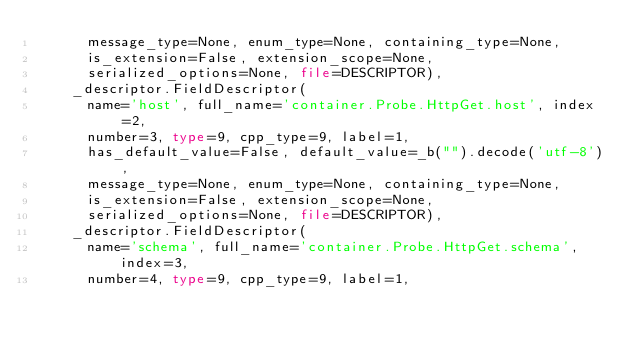<code> <loc_0><loc_0><loc_500><loc_500><_Python_>      message_type=None, enum_type=None, containing_type=None,
      is_extension=False, extension_scope=None,
      serialized_options=None, file=DESCRIPTOR),
    _descriptor.FieldDescriptor(
      name='host', full_name='container.Probe.HttpGet.host', index=2,
      number=3, type=9, cpp_type=9, label=1,
      has_default_value=False, default_value=_b("").decode('utf-8'),
      message_type=None, enum_type=None, containing_type=None,
      is_extension=False, extension_scope=None,
      serialized_options=None, file=DESCRIPTOR),
    _descriptor.FieldDescriptor(
      name='schema', full_name='container.Probe.HttpGet.schema', index=3,
      number=4, type=9, cpp_type=9, label=1,</code> 